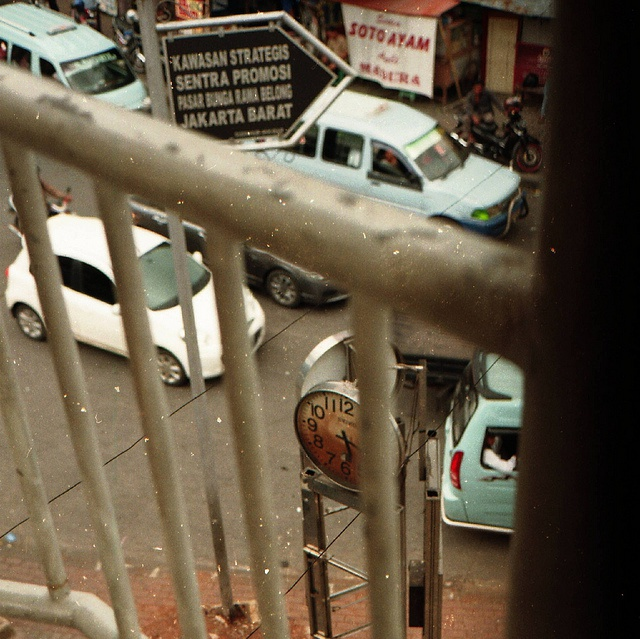Describe the objects in this image and their specific colors. I can see car in black, lightgray, darkgray, and gray tones, car in black, ivory, gray, and darkgray tones, car in black, darkgray, and gray tones, car in black, beige, gray, and lightblue tones, and clock in black, maroon, and gray tones in this image. 